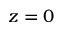Convert formula to latex. <formula><loc_0><loc_0><loc_500><loc_500>z = 0</formula> 